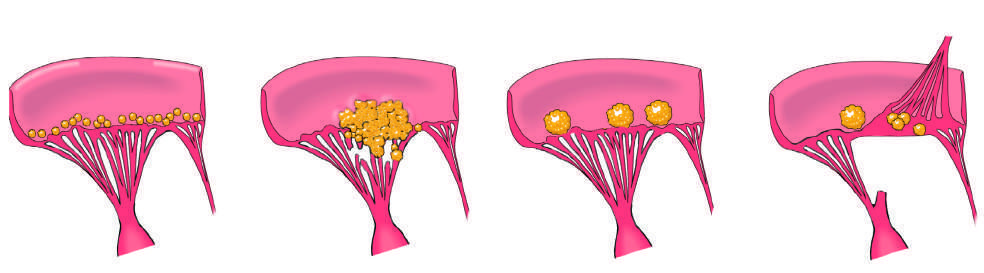what is marked by the appearance of small, warty, inflammatory vegetations along the lines of valve closure?
Answer the question using a single word or phrase. The acute rheumatic fever phase of rheumatic heart disease (rhd) 